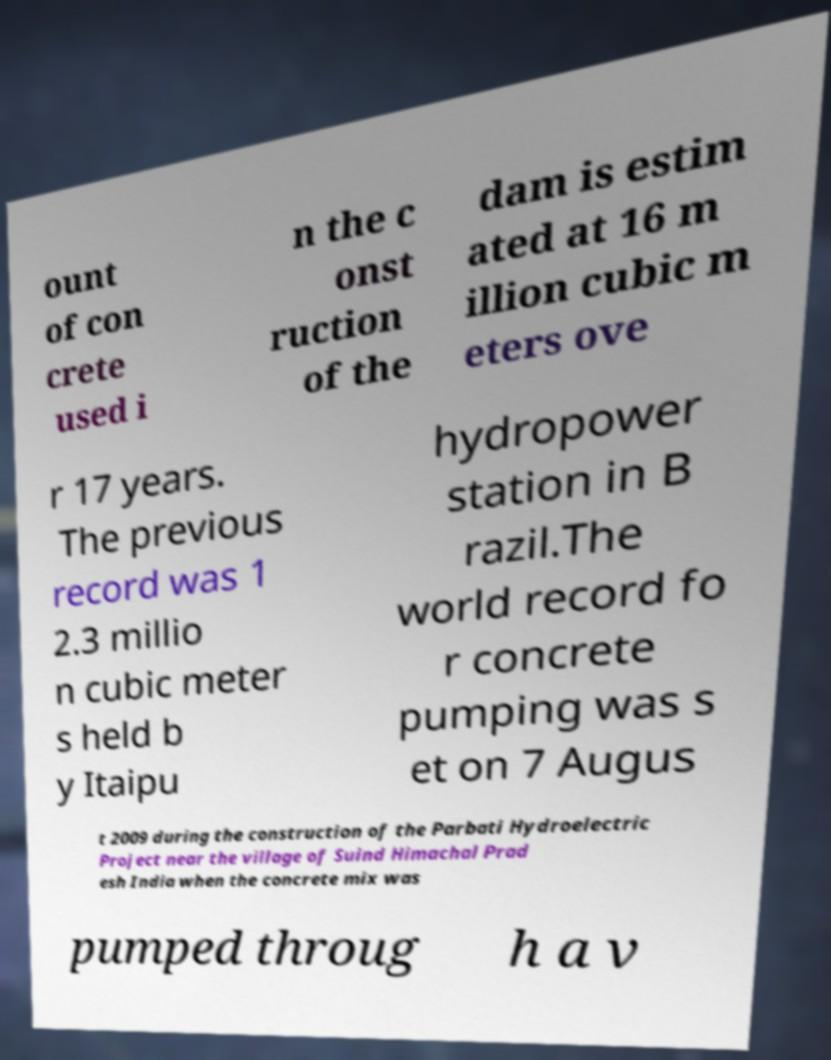Please identify and transcribe the text found in this image. ount of con crete used i n the c onst ruction of the dam is estim ated at 16 m illion cubic m eters ove r 17 years. The previous record was 1 2.3 millio n cubic meter s held b y Itaipu hydropower station in B razil.The world record fo r concrete pumping was s et on 7 Augus t 2009 during the construction of the Parbati Hydroelectric Project near the village of Suind Himachal Prad esh India when the concrete mix was pumped throug h a v 